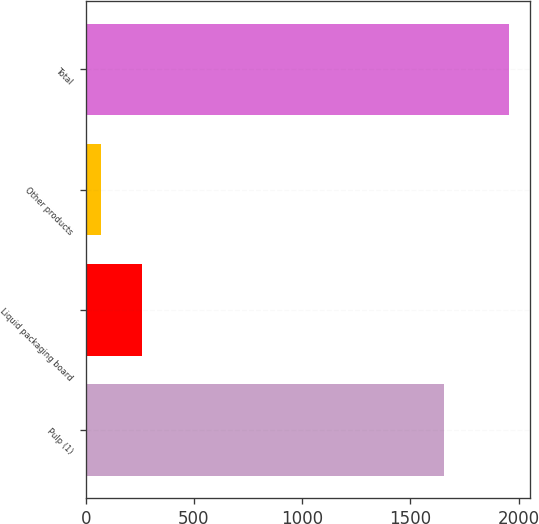<chart> <loc_0><loc_0><loc_500><loc_500><bar_chart><fcel>Pulp (1)<fcel>Liquid packaging board<fcel>Other products<fcel>Total<nl><fcel>1657<fcel>258.6<fcel>70<fcel>1956<nl></chart> 